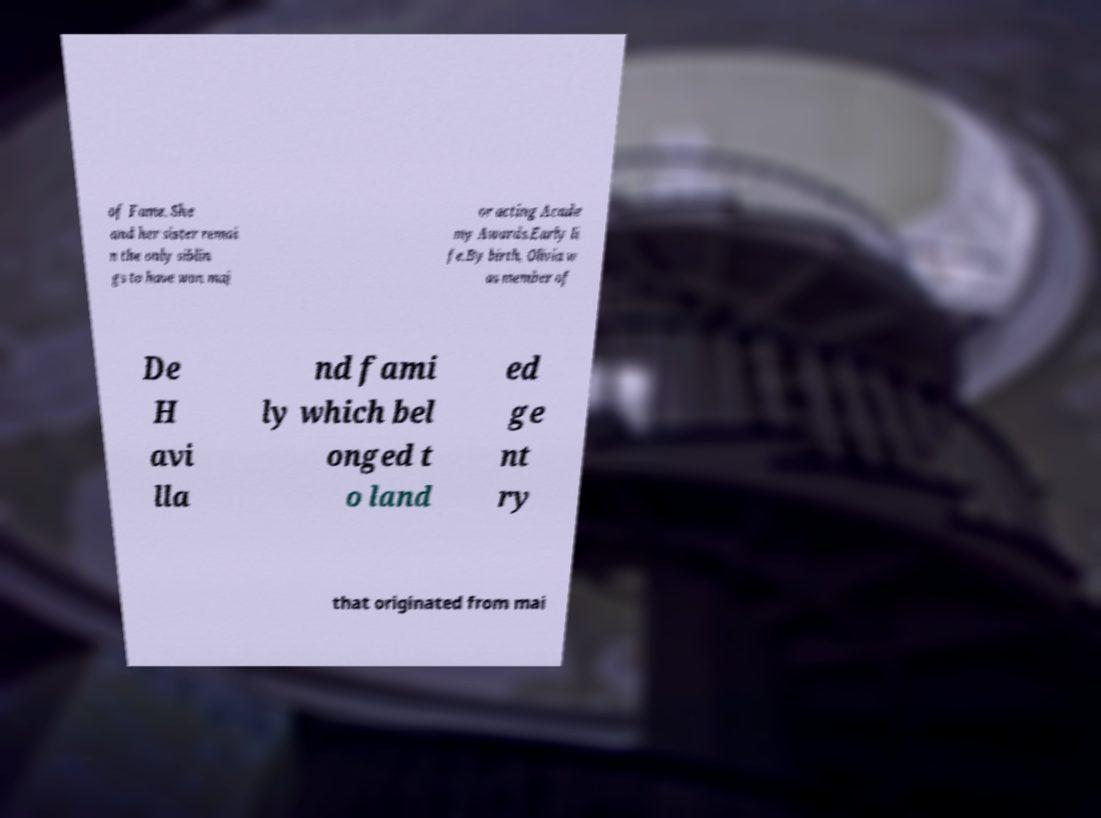What messages or text are displayed in this image? I need them in a readable, typed format. of Fame. She and her sister remai n the only siblin gs to have won maj or acting Acade my Awards.Early li fe.By birth, Olivia w as member of De H avi lla nd fami ly which bel onged t o land ed ge nt ry that originated from mai 